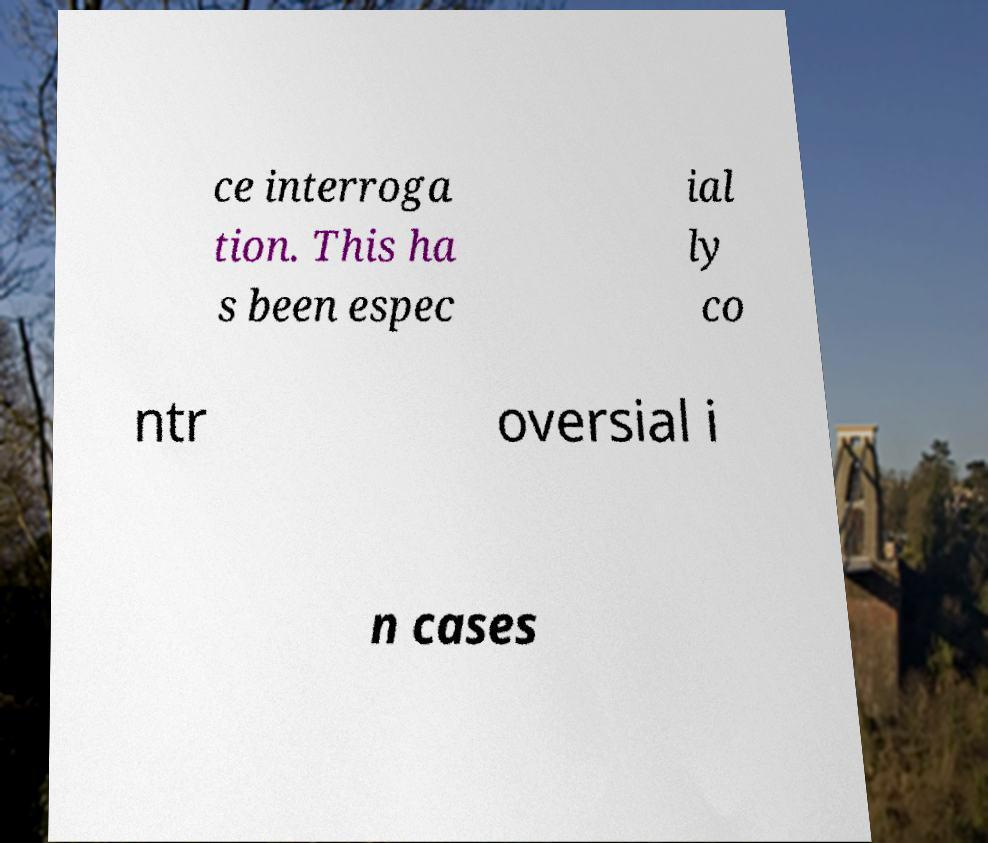Please read and relay the text visible in this image. What does it say? ce interroga tion. This ha s been espec ial ly co ntr oversial i n cases 